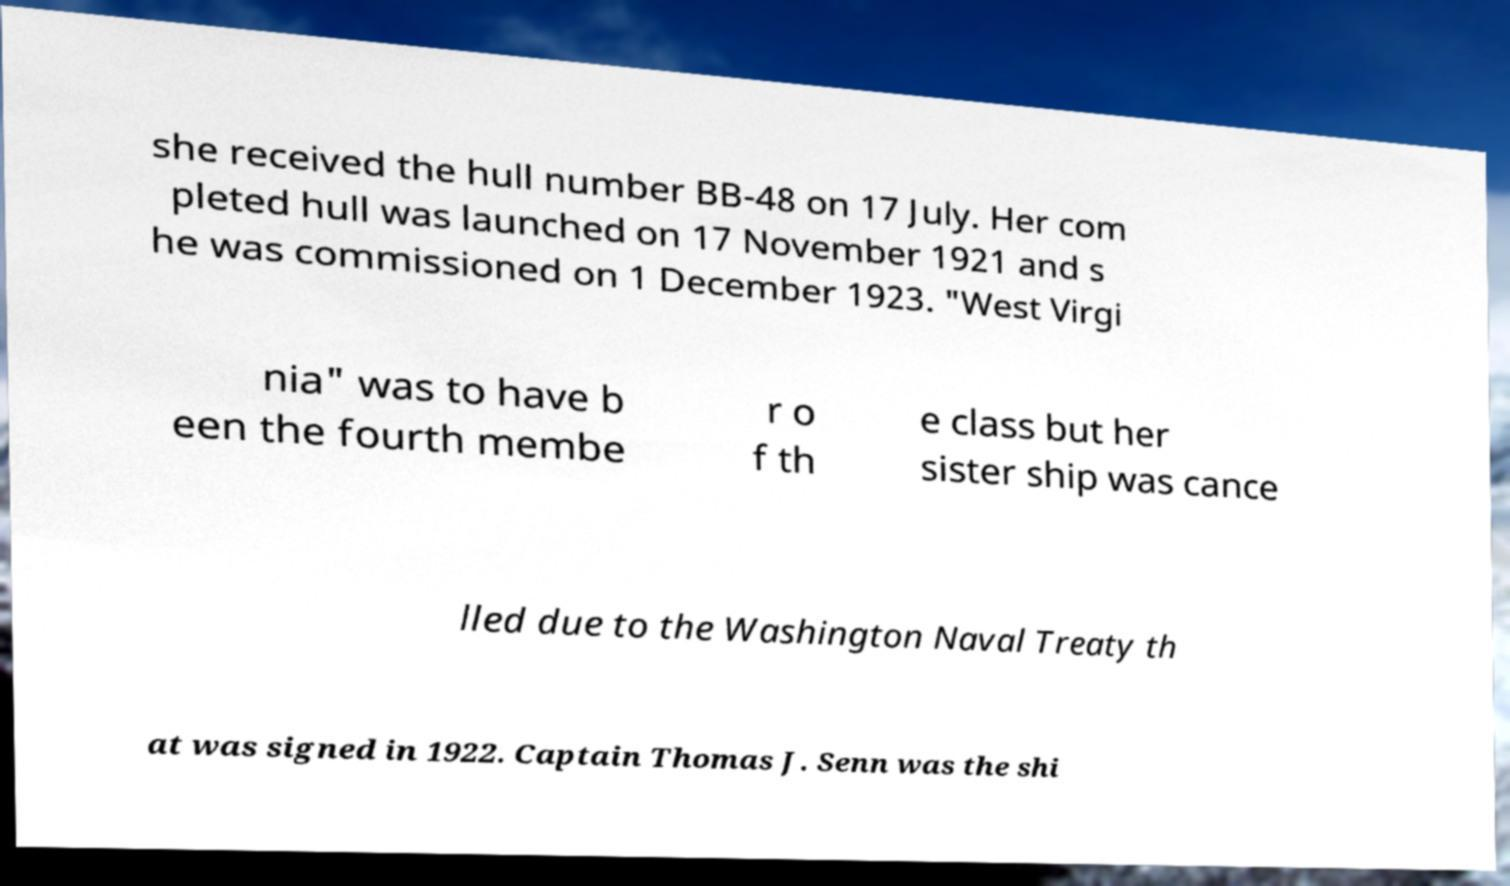Could you assist in decoding the text presented in this image and type it out clearly? she received the hull number BB-48 on 17 July. Her com pleted hull was launched on 17 November 1921 and s he was commissioned on 1 December 1923. "West Virgi nia" was to have b een the fourth membe r o f th e class but her sister ship was cance lled due to the Washington Naval Treaty th at was signed in 1922. Captain Thomas J. Senn was the shi 